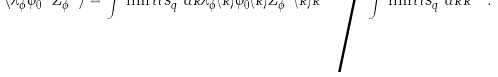Convert formula to latex. <formula><loc_0><loc_0><loc_500><loc_500>\langle \lambda ^ { 2 } _ { \phi } \bar { \phi } ^ { - 4 } _ { 0 } Z ^ { - 1 } _ { \phi } \rangle = \int \lim i t s ^ { \infty } _ { q } d k \lambda ^ { 2 } _ { \phi } ( k ) \bar { \phi } ^ { 4 } _ { 0 } ( k ) Z ^ { - 1 } _ { \phi } ( k ) k ^ { - 5 } { \Big / } \int \lim i t s ^ { \infty } _ { q } d k k ^ { - 5 } .</formula> 